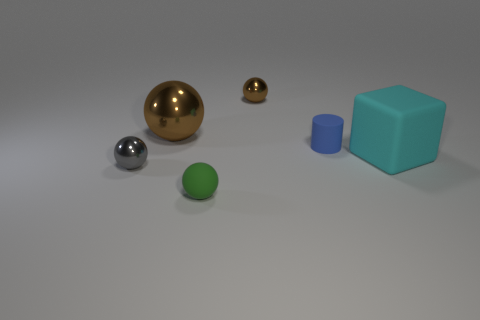What is the size of the green object that is the same shape as the big brown thing?
Provide a short and direct response. Small. How many tiny blue things are made of the same material as the tiny gray thing?
Provide a succinct answer. 0. There is a matte cube; is it the same color as the small metal thing to the right of the green sphere?
Your answer should be very brief. No. Are there more small green objects than brown things?
Ensure brevity in your answer.  No. The tiny rubber ball is what color?
Provide a succinct answer. Green. There is a big thing that is to the right of the matte sphere; does it have the same color as the small rubber cylinder?
Give a very brief answer. No. There is a small ball that is the same color as the large metal sphere; what material is it?
Make the answer very short. Metal. What number of other tiny cylinders are the same color as the rubber cylinder?
Ensure brevity in your answer.  0. Does the tiny rubber object in front of the blue rubber thing have the same shape as the gray metallic thing?
Your answer should be compact. Yes. Is the number of large shiny spheres that are to the right of the big brown metal object less than the number of blocks behind the tiny blue cylinder?
Keep it short and to the point. No. 